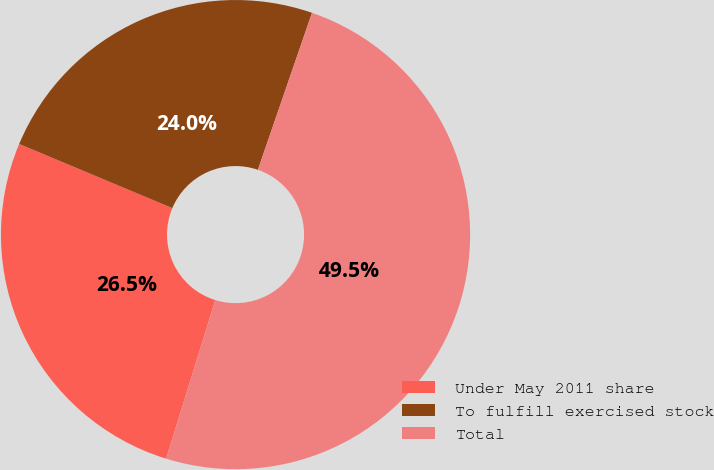Convert chart. <chart><loc_0><loc_0><loc_500><loc_500><pie_chart><fcel>Under May 2011 share<fcel>To fulfill exercised stock<fcel>Total<nl><fcel>26.53%<fcel>23.97%<fcel>49.5%<nl></chart> 